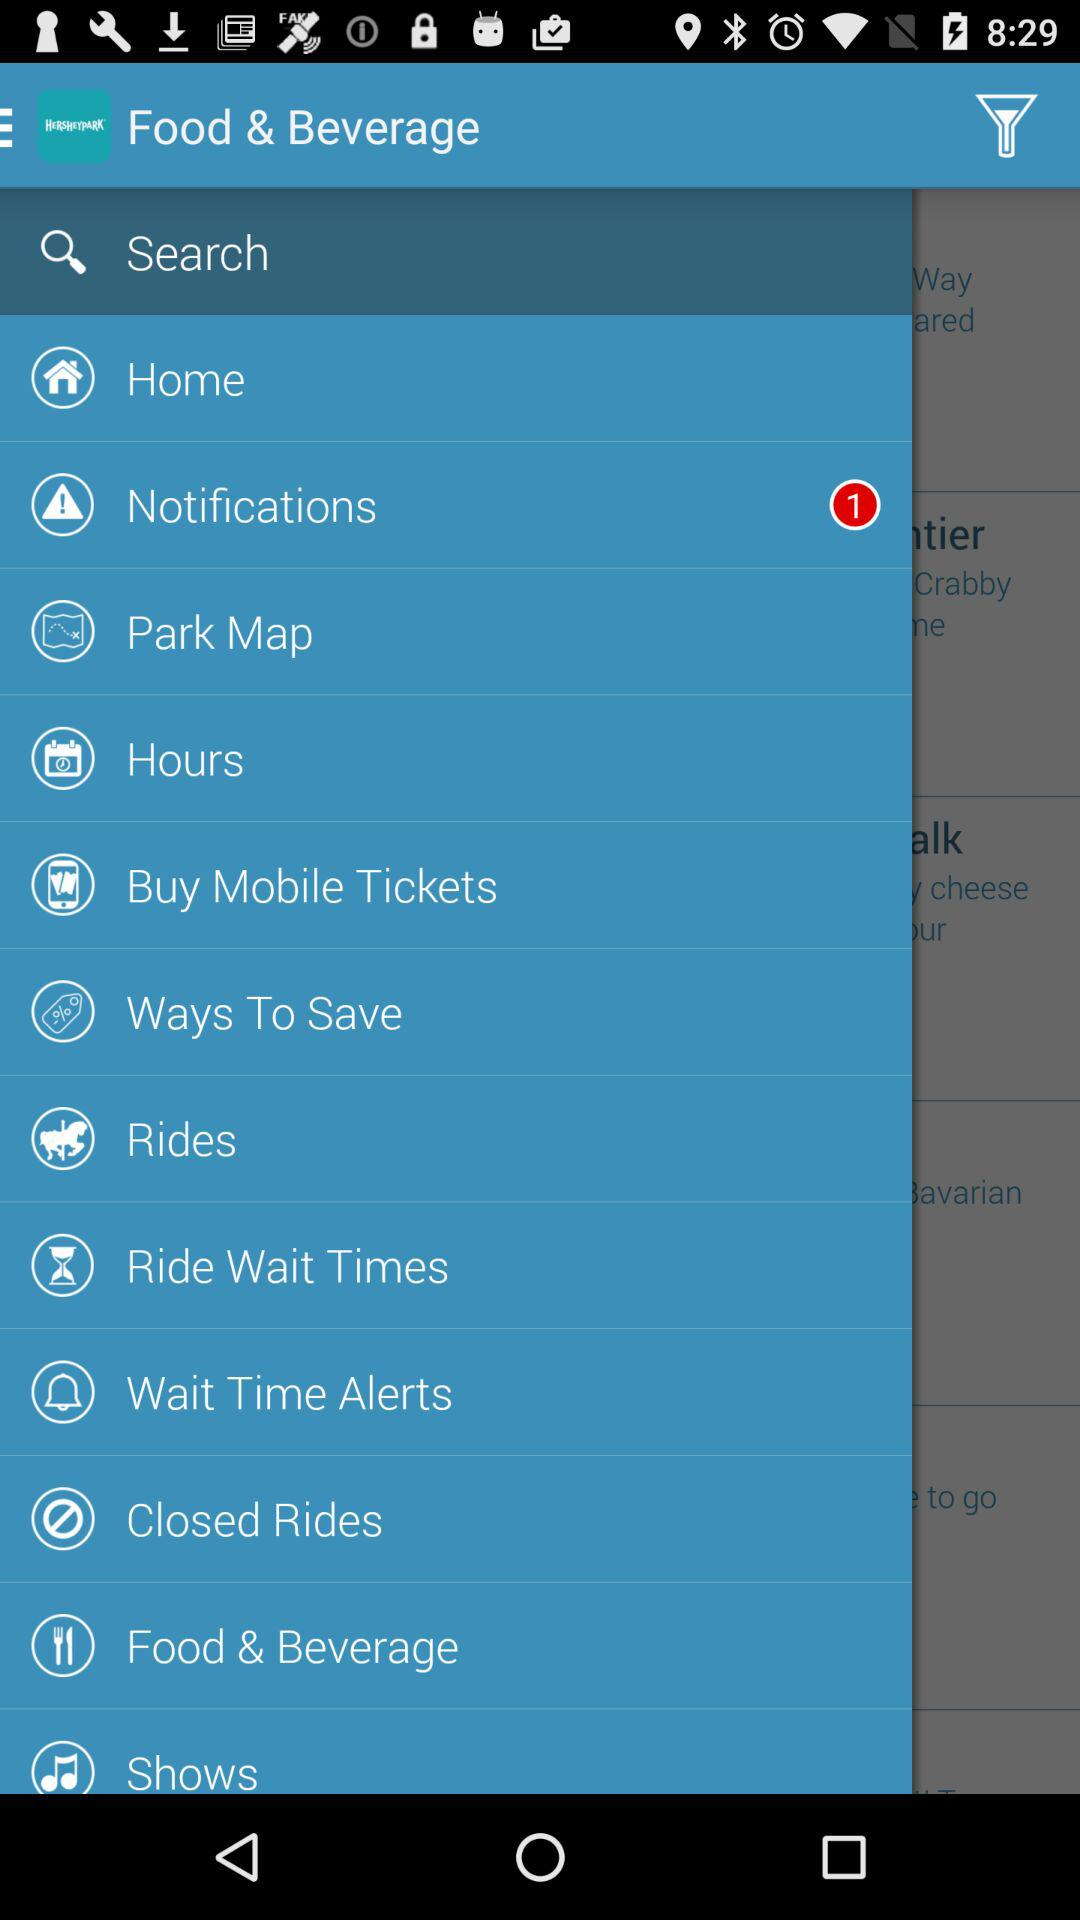How many more notifications are there than ways to save?
Answer the question using a single word or phrase. 1 